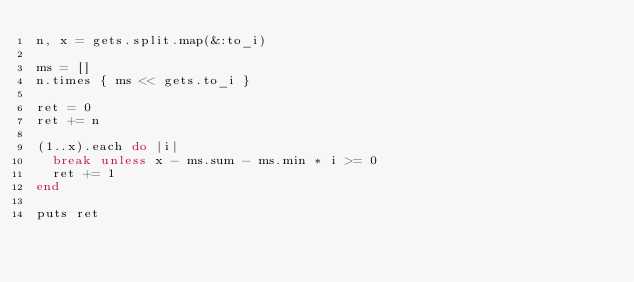<code> <loc_0><loc_0><loc_500><loc_500><_Ruby_>n, x = gets.split.map(&:to_i)

ms = []
n.times { ms << gets.to_i }

ret = 0
ret += n

(1..x).each do |i|
  break unless x - ms.sum - ms.min * i >= 0
  ret += 1
end

puts ret
</code> 